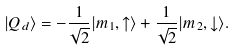<formula> <loc_0><loc_0><loc_500><loc_500>| Q _ { d } \rangle = - \frac { 1 } { \sqrt { 2 } } | m _ { 1 } , \uparrow \rangle + \frac { 1 } { \sqrt { 2 } } | m _ { 2 } , \downarrow \rangle .</formula> 